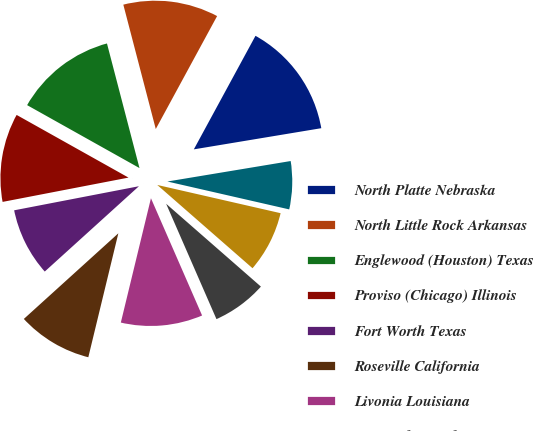Convert chart to OTSL. <chart><loc_0><loc_0><loc_500><loc_500><pie_chart><fcel>North Platte Nebraska<fcel>North Little Rock Arkansas<fcel>Englewood (Houston) Texas<fcel>Proviso (Chicago) Illinois<fcel>Fort Worth Texas<fcel>Roseville California<fcel>Livonia Louisiana<fcel>West Colton California<fcel>Pine Bluff Arkansas<fcel>Neff (Kansas City) Missouri<nl><fcel>14.46%<fcel>11.98%<fcel>12.81%<fcel>11.16%<fcel>8.68%<fcel>9.5%<fcel>10.33%<fcel>7.02%<fcel>7.85%<fcel>6.2%<nl></chart> 